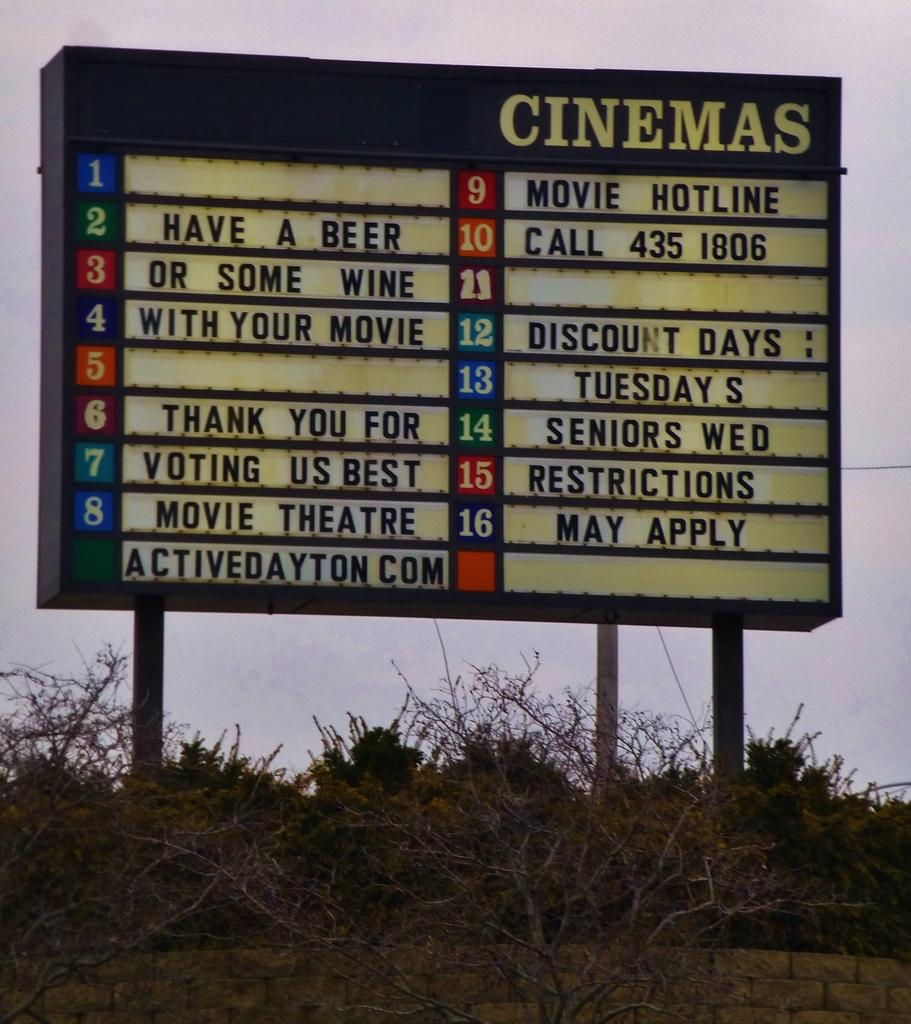<image>
Relay a brief, clear account of the picture shown. A billboard displaying that Tuesdays and Wednesdays are discount days for seniors. 